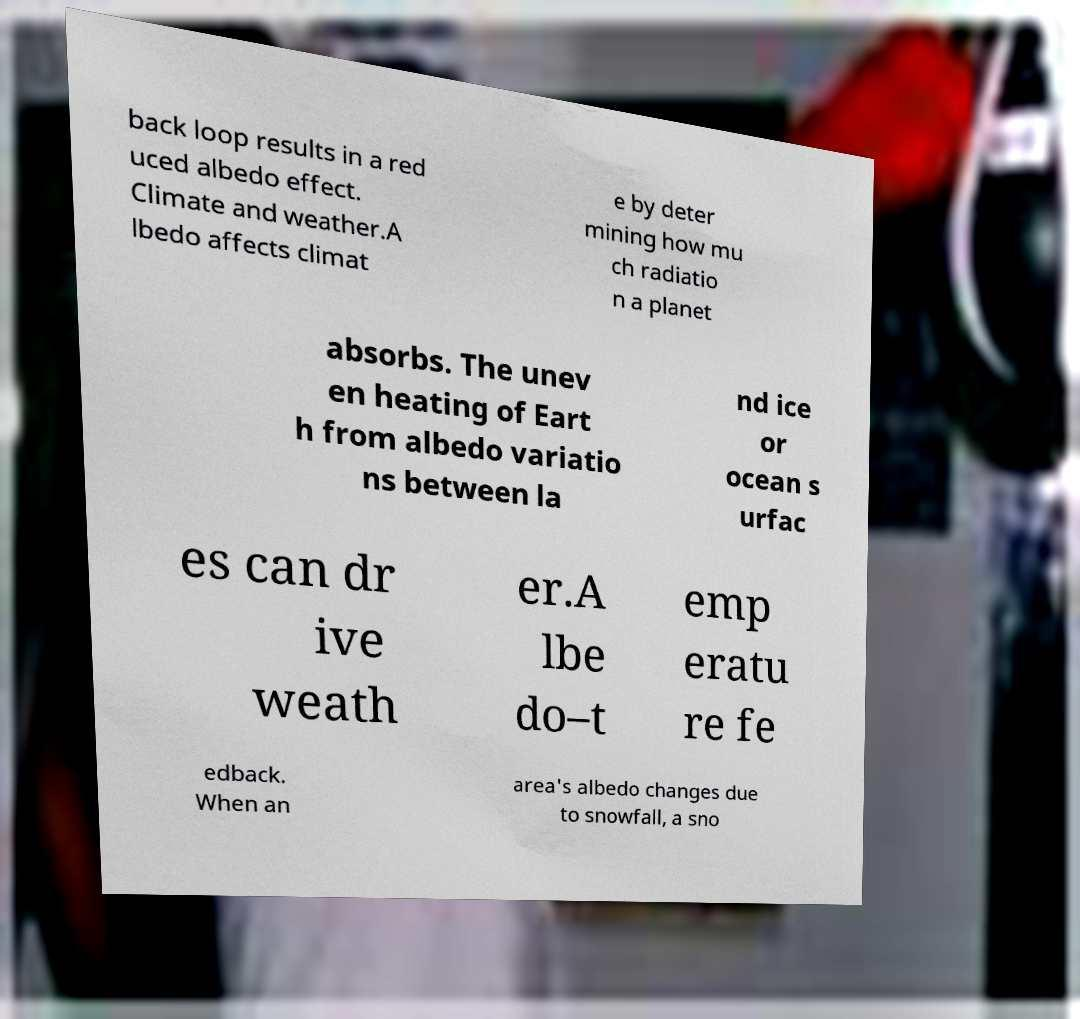I need the written content from this picture converted into text. Can you do that? back loop results in a red uced albedo effect. Climate and weather.A lbedo affects climat e by deter mining how mu ch radiatio n a planet absorbs. The unev en heating of Eart h from albedo variatio ns between la nd ice or ocean s urfac es can dr ive weath er.A lbe do–t emp eratu re fe edback. When an area's albedo changes due to snowfall, a sno 